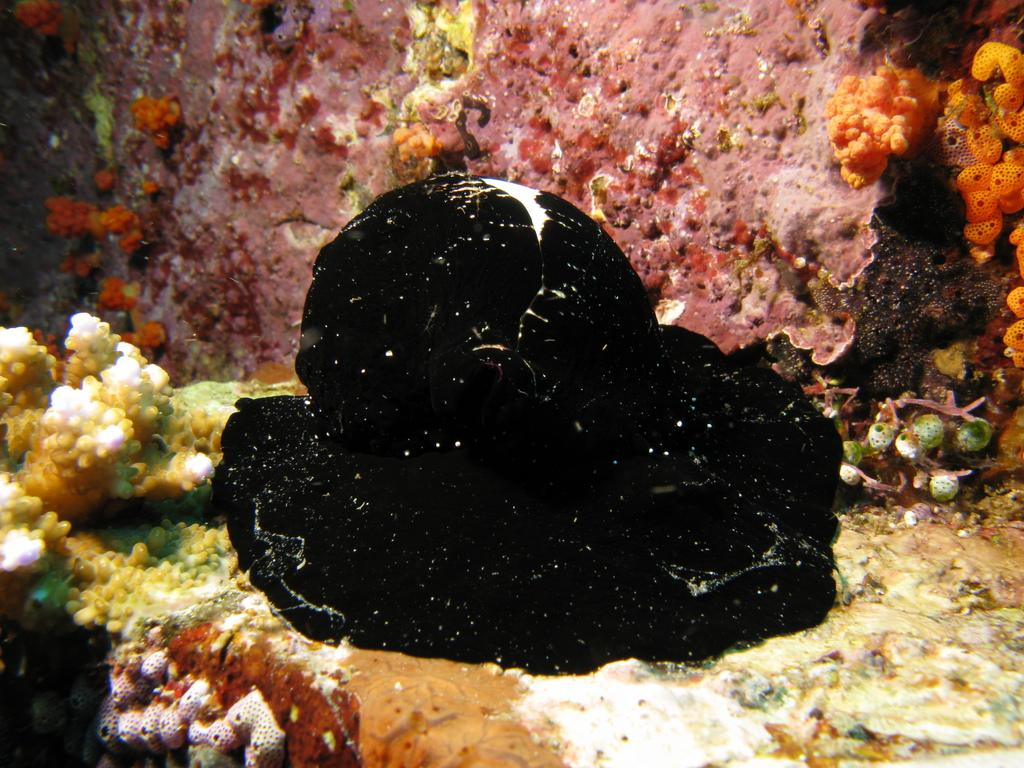What type of environment is depicted in the foreground of the image? There are marine spaces in the foreground of the image. What type of pickle can be seen in the image? There is no pickle present in the image; it features marine spaces in the foreground. 